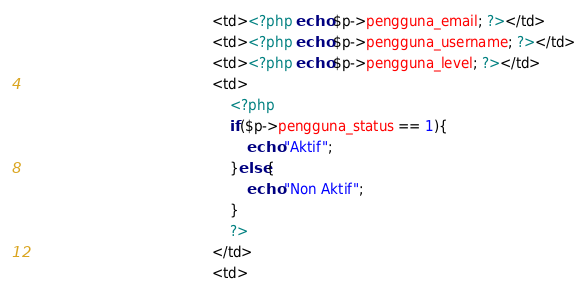<code> <loc_0><loc_0><loc_500><loc_500><_PHP_>											<td><?php echo $p->pengguna_email; ?></td>
											<td><?php echo $p->pengguna_username; ?></td>
											<td><?php echo $p->pengguna_level; ?></td>
											<td>
												<?php
												if($p->pengguna_status == 1){
													echo "Aktif";
												}else{
													echo "Non Aktif";
												}
												?>
											</td>
											<td></code> 